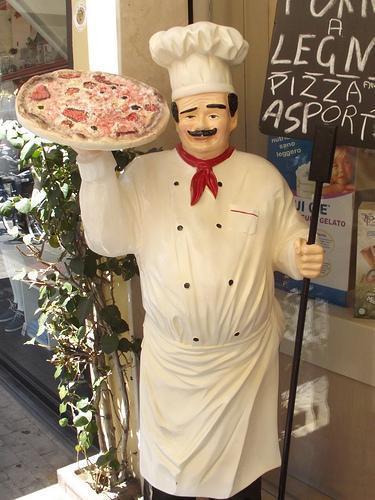How many statues are in this picture?
Give a very brief answer. 1. 